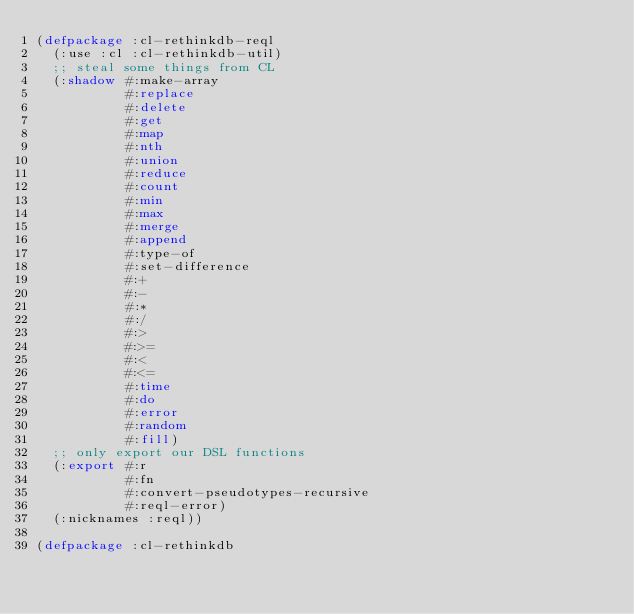<code> <loc_0><loc_0><loc_500><loc_500><_Lisp_>(defpackage :cl-rethinkdb-reql
  (:use :cl :cl-rethinkdb-util)
  ;; steal some things from CL
  (:shadow #:make-array
           #:replace
           #:delete
           #:get
           #:map
           #:nth
           #:union
           #:reduce
           #:count
           #:min
           #:max
           #:merge
           #:append
           #:type-of
           #:set-difference
           #:+
           #:-
           #:*
           #:/
           #:>
           #:>=
           #:<
           #:<=
           #:time
           #:do
           #:error
           #:random
           #:fill)
  ;; only export our DSL functions
  (:export #:r
           #:fn
           #:convert-pseudotypes-recursive
           #:reql-error)
  (:nicknames :reql))

(defpackage :cl-rethinkdb</code> 